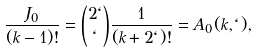<formula> <loc_0><loc_0><loc_500><loc_500>\frac { J _ { 0 } } { ( k - 1 ) ! } = \binom { 2 \ell } { \ell } \frac { 1 } { ( k + 2 \ell ) ! } = A _ { 0 } ( k , \ell ) ,</formula> 